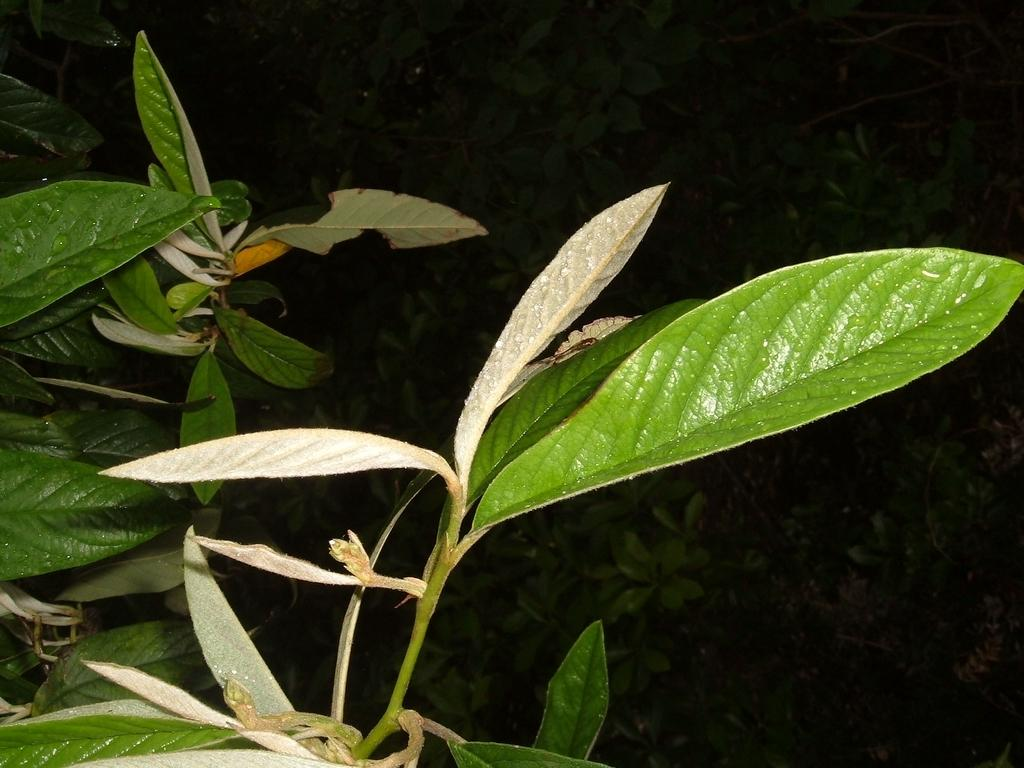What type of vegetation can be seen in the image? There are leaves and stems in the image. What is visible in the background of the image? There are plants in the background of the image. How many children are playing with the baby in the image? There are no children or babies present in the image; it features leaves, stems, and plants. 